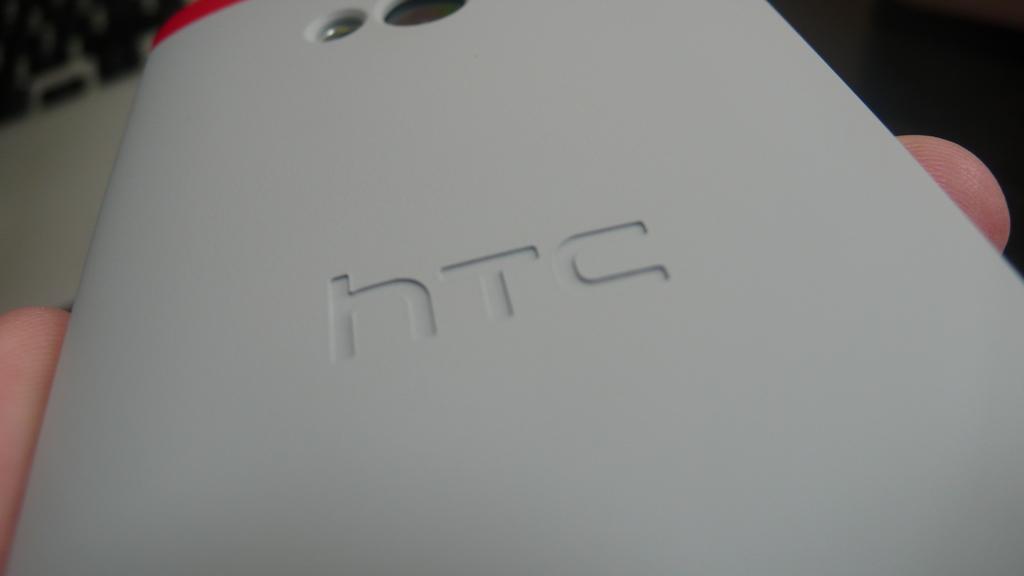What brand phone is this?
Provide a short and direct response. Htc. 